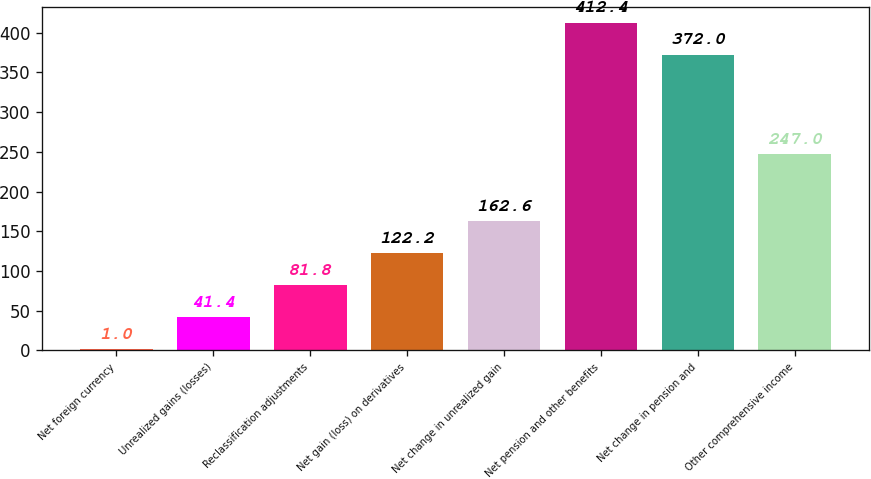Convert chart. <chart><loc_0><loc_0><loc_500><loc_500><bar_chart><fcel>Net foreign currency<fcel>Unrealized gains (losses)<fcel>Reclassification adjustments<fcel>Net gain (loss) on derivatives<fcel>Net change in unrealized gain<fcel>Net pension and other benefits<fcel>Net change in pension and<fcel>Other comprehensive income<nl><fcel>1<fcel>41.4<fcel>81.8<fcel>122.2<fcel>162.6<fcel>412.4<fcel>372<fcel>247<nl></chart> 